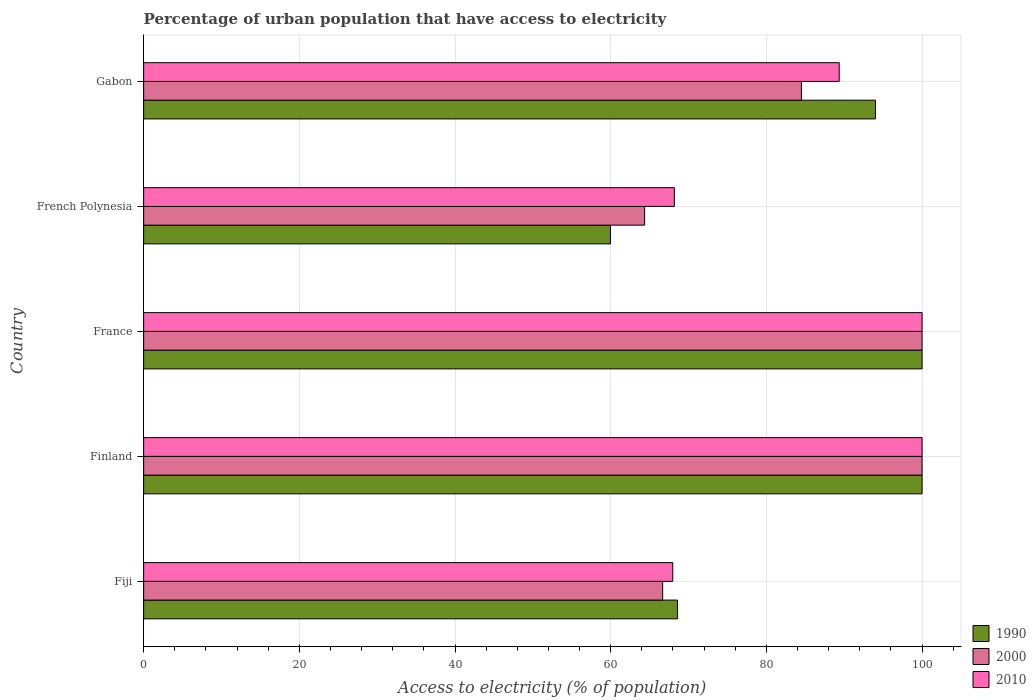Are the number of bars per tick equal to the number of legend labels?
Ensure brevity in your answer.  Yes. Are the number of bars on each tick of the Y-axis equal?
Provide a short and direct response. Yes. How many bars are there on the 2nd tick from the top?
Make the answer very short. 3. How many bars are there on the 4th tick from the bottom?
Offer a very short reply. 3. What is the label of the 5th group of bars from the top?
Give a very brief answer. Fiji. In how many cases, is the number of bars for a given country not equal to the number of legend labels?
Offer a terse response. 0. What is the percentage of urban population that have access to electricity in 2010 in Finland?
Your answer should be compact. 100. Across all countries, what is the minimum percentage of urban population that have access to electricity in 2010?
Make the answer very short. 67.97. In which country was the percentage of urban population that have access to electricity in 2000 minimum?
Give a very brief answer. French Polynesia. What is the total percentage of urban population that have access to electricity in 2010 in the graph?
Give a very brief answer. 425.5. What is the difference between the percentage of urban population that have access to electricity in 2000 in Fiji and that in French Polynesia?
Ensure brevity in your answer.  2.32. What is the difference between the percentage of urban population that have access to electricity in 2010 in French Polynesia and the percentage of urban population that have access to electricity in 1990 in France?
Ensure brevity in your answer.  -31.82. What is the average percentage of urban population that have access to electricity in 2000 per country?
Your response must be concise. 83.11. What is the difference between the percentage of urban population that have access to electricity in 2010 and percentage of urban population that have access to electricity in 1990 in Finland?
Ensure brevity in your answer.  0. In how many countries, is the percentage of urban population that have access to electricity in 2000 greater than 88 %?
Provide a succinct answer. 2. What is the ratio of the percentage of urban population that have access to electricity in 1990 in Finland to that in Gabon?
Keep it short and to the point. 1.06. Is the difference between the percentage of urban population that have access to electricity in 2010 in Fiji and Finland greater than the difference between the percentage of urban population that have access to electricity in 1990 in Fiji and Finland?
Make the answer very short. No. What is the difference between the highest and the lowest percentage of urban population that have access to electricity in 2010?
Make the answer very short. 32.03. What does the 1st bar from the top in Fiji represents?
Give a very brief answer. 2010. How many countries are there in the graph?
Your answer should be compact. 5. Are the values on the major ticks of X-axis written in scientific E-notation?
Make the answer very short. No. Does the graph contain any zero values?
Provide a short and direct response. No. Does the graph contain grids?
Keep it short and to the point. Yes. Where does the legend appear in the graph?
Ensure brevity in your answer.  Bottom right. What is the title of the graph?
Provide a short and direct response. Percentage of urban population that have access to electricity. What is the label or title of the X-axis?
Your answer should be compact. Access to electricity (% of population). What is the Access to electricity (% of population) of 1990 in Fiji?
Provide a short and direct response. 68.59. What is the Access to electricity (% of population) in 2000 in Fiji?
Offer a very short reply. 66.68. What is the Access to electricity (% of population) in 2010 in Fiji?
Give a very brief answer. 67.97. What is the Access to electricity (% of population) of 2010 in Finland?
Your response must be concise. 100. What is the Access to electricity (% of population) in 1990 in France?
Provide a short and direct response. 100. What is the Access to electricity (% of population) in 1990 in French Polynesia?
Make the answer very short. 59.97. What is the Access to electricity (% of population) of 2000 in French Polynesia?
Your response must be concise. 64.36. What is the Access to electricity (% of population) of 2010 in French Polynesia?
Your response must be concise. 68.18. What is the Access to electricity (% of population) in 1990 in Gabon?
Provide a short and direct response. 94.02. What is the Access to electricity (% of population) in 2000 in Gabon?
Provide a short and direct response. 84.5. What is the Access to electricity (% of population) of 2010 in Gabon?
Make the answer very short. 89.35. Across all countries, what is the maximum Access to electricity (% of population) in 2010?
Your response must be concise. 100. Across all countries, what is the minimum Access to electricity (% of population) in 1990?
Provide a short and direct response. 59.97. Across all countries, what is the minimum Access to electricity (% of population) in 2000?
Give a very brief answer. 64.36. Across all countries, what is the minimum Access to electricity (% of population) in 2010?
Your response must be concise. 67.97. What is the total Access to electricity (% of population) in 1990 in the graph?
Offer a terse response. 422.57. What is the total Access to electricity (% of population) in 2000 in the graph?
Give a very brief answer. 415.53. What is the total Access to electricity (% of population) of 2010 in the graph?
Provide a short and direct response. 425.5. What is the difference between the Access to electricity (% of population) in 1990 in Fiji and that in Finland?
Your answer should be very brief. -31.41. What is the difference between the Access to electricity (% of population) in 2000 in Fiji and that in Finland?
Offer a terse response. -33.32. What is the difference between the Access to electricity (% of population) of 2010 in Fiji and that in Finland?
Give a very brief answer. -32.03. What is the difference between the Access to electricity (% of population) in 1990 in Fiji and that in France?
Give a very brief answer. -31.41. What is the difference between the Access to electricity (% of population) of 2000 in Fiji and that in France?
Offer a very short reply. -33.32. What is the difference between the Access to electricity (% of population) of 2010 in Fiji and that in France?
Keep it short and to the point. -32.03. What is the difference between the Access to electricity (% of population) in 1990 in Fiji and that in French Polynesia?
Your answer should be very brief. 8.62. What is the difference between the Access to electricity (% of population) of 2000 in Fiji and that in French Polynesia?
Your answer should be very brief. 2.32. What is the difference between the Access to electricity (% of population) of 2010 in Fiji and that in French Polynesia?
Keep it short and to the point. -0.2. What is the difference between the Access to electricity (% of population) in 1990 in Fiji and that in Gabon?
Your answer should be compact. -25.43. What is the difference between the Access to electricity (% of population) in 2000 in Fiji and that in Gabon?
Your answer should be very brief. -17.83. What is the difference between the Access to electricity (% of population) in 2010 in Fiji and that in Gabon?
Provide a succinct answer. -21.38. What is the difference between the Access to electricity (% of population) of 1990 in Finland and that in France?
Provide a succinct answer. 0. What is the difference between the Access to electricity (% of population) of 2010 in Finland and that in France?
Provide a succinct answer. 0. What is the difference between the Access to electricity (% of population) in 1990 in Finland and that in French Polynesia?
Your answer should be compact. 40.03. What is the difference between the Access to electricity (% of population) in 2000 in Finland and that in French Polynesia?
Provide a short and direct response. 35.64. What is the difference between the Access to electricity (% of population) in 2010 in Finland and that in French Polynesia?
Ensure brevity in your answer.  31.82. What is the difference between the Access to electricity (% of population) in 1990 in Finland and that in Gabon?
Offer a terse response. 5.98. What is the difference between the Access to electricity (% of population) of 2000 in Finland and that in Gabon?
Make the answer very short. 15.5. What is the difference between the Access to electricity (% of population) of 2010 in Finland and that in Gabon?
Provide a succinct answer. 10.65. What is the difference between the Access to electricity (% of population) of 1990 in France and that in French Polynesia?
Ensure brevity in your answer.  40.03. What is the difference between the Access to electricity (% of population) of 2000 in France and that in French Polynesia?
Offer a terse response. 35.64. What is the difference between the Access to electricity (% of population) in 2010 in France and that in French Polynesia?
Your answer should be very brief. 31.82. What is the difference between the Access to electricity (% of population) of 1990 in France and that in Gabon?
Give a very brief answer. 5.98. What is the difference between the Access to electricity (% of population) of 2000 in France and that in Gabon?
Provide a succinct answer. 15.5. What is the difference between the Access to electricity (% of population) of 2010 in France and that in Gabon?
Ensure brevity in your answer.  10.65. What is the difference between the Access to electricity (% of population) in 1990 in French Polynesia and that in Gabon?
Your answer should be compact. -34.05. What is the difference between the Access to electricity (% of population) in 2000 in French Polynesia and that in Gabon?
Offer a very short reply. -20.14. What is the difference between the Access to electricity (% of population) in 2010 in French Polynesia and that in Gabon?
Give a very brief answer. -21.18. What is the difference between the Access to electricity (% of population) in 1990 in Fiji and the Access to electricity (% of population) in 2000 in Finland?
Offer a very short reply. -31.41. What is the difference between the Access to electricity (% of population) in 1990 in Fiji and the Access to electricity (% of population) in 2010 in Finland?
Give a very brief answer. -31.41. What is the difference between the Access to electricity (% of population) of 2000 in Fiji and the Access to electricity (% of population) of 2010 in Finland?
Provide a short and direct response. -33.32. What is the difference between the Access to electricity (% of population) in 1990 in Fiji and the Access to electricity (% of population) in 2000 in France?
Ensure brevity in your answer.  -31.41. What is the difference between the Access to electricity (% of population) in 1990 in Fiji and the Access to electricity (% of population) in 2010 in France?
Ensure brevity in your answer.  -31.41. What is the difference between the Access to electricity (% of population) of 2000 in Fiji and the Access to electricity (% of population) of 2010 in France?
Offer a terse response. -33.32. What is the difference between the Access to electricity (% of population) of 1990 in Fiji and the Access to electricity (% of population) of 2000 in French Polynesia?
Ensure brevity in your answer.  4.23. What is the difference between the Access to electricity (% of population) in 1990 in Fiji and the Access to electricity (% of population) in 2010 in French Polynesia?
Provide a short and direct response. 0.41. What is the difference between the Access to electricity (% of population) of 2000 in Fiji and the Access to electricity (% of population) of 2010 in French Polynesia?
Offer a very short reply. -1.5. What is the difference between the Access to electricity (% of population) in 1990 in Fiji and the Access to electricity (% of population) in 2000 in Gabon?
Ensure brevity in your answer.  -15.91. What is the difference between the Access to electricity (% of population) of 1990 in Fiji and the Access to electricity (% of population) of 2010 in Gabon?
Make the answer very short. -20.77. What is the difference between the Access to electricity (% of population) of 2000 in Fiji and the Access to electricity (% of population) of 2010 in Gabon?
Give a very brief answer. -22.68. What is the difference between the Access to electricity (% of population) in 1990 in Finland and the Access to electricity (% of population) in 2010 in France?
Offer a very short reply. 0. What is the difference between the Access to electricity (% of population) in 2000 in Finland and the Access to electricity (% of population) in 2010 in France?
Your answer should be compact. 0. What is the difference between the Access to electricity (% of population) of 1990 in Finland and the Access to electricity (% of population) of 2000 in French Polynesia?
Offer a very short reply. 35.64. What is the difference between the Access to electricity (% of population) of 1990 in Finland and the Access to electricity (% of population) of 2010 in French Polynesia?
Ensure brevity in your answer.  31.82. What is the difference between the Access to electricity (% of population) in 2000 in Finland and the Access to electricity (% of population) in 2010 in French Polynesia?
Offer a terse response. 31.82. What is the difference between the Access to electricity (% of population) in 1990 in Finland and the Access to electricity (% of population) in 2000 in Gabon?
Give a very brief answer. 15.5. What is the difference between the Access to electricity (% of population) of 1990 in Finland and the Access to electricity (% of population) of 2010 in Gabon?
Your answer should be very brief. 10.65. What is the difference between the Access to electricity (% of population) in 2000 in Finland and the Access to electricity (% of population) in 2010 in Gabon?
Provide a short and direct response. 10.65. What is the difference between the Access to electricity (% of population) in 1990 in France and the Access to electricity (% of population) in 2000 in French Polynesia?
Your answer should be compact. 35.64. What is the difference between the Access to electricity (% of population) of 1990 in France and the Access to electricity (% of population) of 2010 in French Polynesia?
Your response must be concise. 31.82. What is the difference between the Access to electricity (% of population) of 2000 in France and the Access to electricity (% of population) of 2010 in French Polynesia?
Give a very brief answer. 31.82. What is the difference between the Access to electricity (% of population) of 1990 in France and the Access to electricity (% of population) of 2000 in Gabon?
Keep it short and to the point. 15.5. What is the difference between the Access to electricity (% of population) of 1990 in France and the Access to electricity (% of population) of 2010 in Gabon?
Your answer should be compact. 10.65. What is the difference between the Access to electricity (% of population) of 2000 in France and the Access to electricity (% of population) of 2010 in Gabon?
Make the answer very short. 10.65. What is the difference between the Access to electricity (% of population) in 1990 in French Polynesia and the Access to electricity (% of population) in 2000 in Gabon?
Make the answer very short. -24.53. What is the difference between the Access to electricity (% of population) of 1990 in French Polynesia and the Access to electricity (% of population) of 2010 in Gabon?
Your answer should be very brief. -29.39. What is the difference between the Access to electricity (% of population) of 2000 in French Polynesia and the Access to electricity (% of population) of 2010 in Gabon?
Give a very brief answer. -25. What is the average Access to electricity (% of population) of 1990 per country?
Make the answer very short. 84.51. What is the average Access to electricity (% of population) in 2000 per country?
Your response must be concise. 83.11. What is the average Access to electricity (% of population) in 2010 per country?
Your answer should be compact. 85.1. What is the difference between the Access to electricity (% of population) of 1990 and Access to electricity (% of population) of 2000 in Fiji?
Make the answer very short. 1.91. What is the difference between the Access to electricity (% of population) in 1990 and Access to electricity (% of population) in 2010 in Fiji?
Your answer should be compact. 0.62. What is the difference between the Access to electricity (% of population) of 2000 and Access to electricity (% of population) of 2010 in Fiji?
Ensure brevity in your answer.  -1.3. What is the difference between the Access to electricity (% of population) in 2000 and Access to electricity (% of population) in 2010 in Finland?
Keep it short and to the point. 0. What is the difference between the Access to electricity (% of population) of 1990 and Access to electricity (% of population) of 2000 in France?
Provide a short and direct response. 0. What is the difference between the Access to electricity (% of population) in 1990 and Access to electricity (% of population) in 2010 in France?
Provide a succinct answer. 0. What is the difference between the Access to electricity (% of population) of 1990 and Access to electricity (% of population) of 2000 in French Polynesia?
Offer a very short reply. -4.39. What is the difference between the Access to electricity (% of population) in 1990 and Access to electricity (% of population) in 2010 in French Polynesia?
Provide a short and direct response. -8.21. What is the difference between the Access to electricity (% of population) in 2000 and Access to electricity (% of population) in 2010 in French Polynesia?
Your answer should be very brief. -3.82. What is the difference between the Access to electricity (% of population) of 1990 and Access to electricity (% of population) of 2000 in Gabon?
Your response must be concise. 9.51. What is the difference between the Access to electricity (% of population) in 1990 and Access to electricity (% of population) in 2010 in Gabon?
Provide a succinct answer. 4.66. What is the difference between the Access to electricity (% of population) in 2000 and Access to electricity (% of population) in 2010 in Gabon?
Provide a succinct answer. -4.85. What is the ratio of the Access to electricity (% of population) of 1990 in Fiji to that in Finland?
Give a very brief answer. 0.69. What is the ratio of the Access to electricity (% of population) in 2000 in Fiji to that in Finland?
Your response must be concise. 0.67. What is the ratio of the Access to electricity (% of population) of 2010 in Fiji to that in Finland?
Make the answer very short. 0.68. What is the ratio of the Access to electricity (% of population) in 1990 in Fiji to that in France?
Give a very brief answer. 0.69. What is the ratio of the Access to electricity (% of population) of 2000 in Fiji to that in France?
Make the answer very short. 0.67. What is the ratio of the Access to electricity (% of population) in 2010 in Fiji to that in France?
Your answer should be very brief. 0.68. What is the ratio of the Access to electricity (% of population) of 1990 in Fiji to that in French Polynesia?
Keep it short and to the point. 1.14. What is the ratio of the Access to electricity (% of population) in 2000 in Fiji to that in French Polynesia?
Ensure brevity in your answer.  1.04. What is the ratio of the Access to electricity (% of population) in 2010 in Fiji to that in French Polynesia?
Give a very brief answer. 1. What is the ratio of the Access to electricity (% of population) of 1990 in Fiji to that in Gabon?
Your answer should be compact. 0.73. What is the ratio of the Access to electricity (% of population) of 2000 in Fiji to that in Gabon?
Offer a terse response. 0.79. What is the ratio of the Access to electricity (% of population) in 2010 in Fiji to that in Gabon?
Your answer should be very brief. 0.76. What is the ratio of the Access to electricity (% of population) of 1990 in Finland to that in France?
Your response must be concise. 1. What is the ratio of the Access to electricity (% of population) in 2010 in Finland to that in France?
Ensure brevity in your answer.  1. What is the ratio of the Access to electricity (% of population) of 1990 in Finland to that in French Polynesia?
Provide a succinct answer. 1.67. What is the ratio of the Access to electricity (% of population) of 2000 in Finland to that in French Polynesia?
Your answer should be compact. 1.55. What is the ratio of the Access to electricity (% of population) in 2010 in Finland to that in French Polynesia?
Offer a terse response. 1.47. What is the ratio of the Access to electricity (% of population) of 1990 in Finland to that in Gabon?
Provide a short and direct response. 1.06. What is the ratio of the Access to electricity (% of population) in 2000 in Finland to that in Gabon?
Your answer should be very brief. 1.18. What is the ratio of the Access to electricity (% of population) in 2010 in Finland to that in Gabon?
Keep it short and to the point. 1.12. What is the ratio of the Access to electricity (% of population) of 1990 in France to that in French Polynesia?
Give a very brief answer. 1.67. What is the ratio of the Access to electricity (% of population) in 2000 in France to that in French Polynesia?
Offer a very short reply. 1.55. What is the ratio of the Access to electricity (% of population) of 2010 in France to that in French Polynesia?
Offer a terse response. 1.47. What is the ratio of the Access to electricity (% of population) of 1990 in France to that in Gabon?
Make the answer very short. 1.06. What is the ratio of the Access to electricity (% of population) in 2000 in France to that in Gabon?
Make the answer very short. 1.18. What is the ratio of the Access to electricity (% of population) in 2010 in France to that in Gabon?
Give a very brief answer. 1.12. What is the ratio of the Access to electricity (% of population) of 1990 in French Polynesia to that in Gabon?
Provide a succinct answer. 0.64. What is the ratio of the Access to electricity (% of population) of 2000 in French Polynesia to that in Gabon?
Your answer should be compact. 0.76. What is the ratio of the Access to electricity (% of population) in 2010 in French Polynesia to that in Gabon?
Offer a very short reply. 0.76. What is the difference between the highest and the lowest Access to electricity (% of population) in 1990?
Provide a succinct answer. 40.03. What is the difference between the highest and the lowest Access to electricity (% of population) of 2000?
Provide a short and direct response. 35.64. What is the difference between the highest and the lowest Access to electricity (% of population) in 2010?
Offer a very short reply. 32.03. 